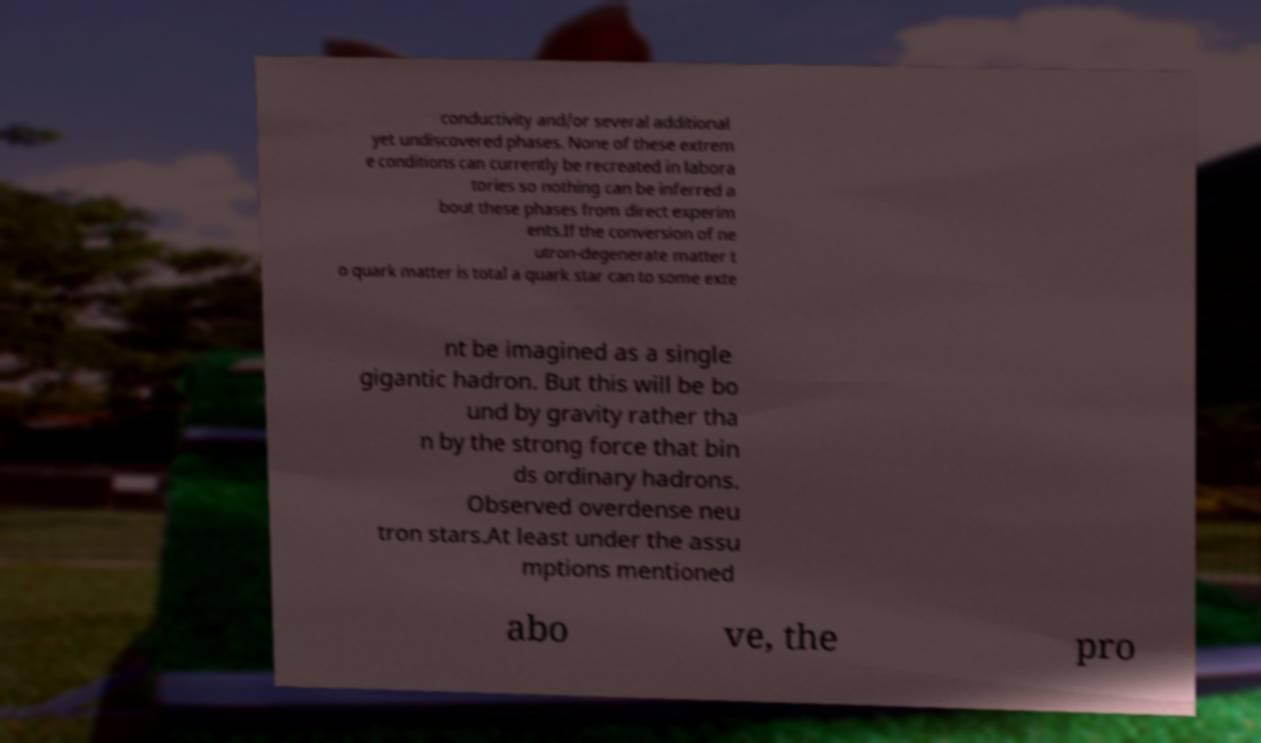Could you extract and type out the text from this image? conductivity and/or several additional yet undiscovered phases. None of these extrem e conditions can currently be recreated in labora tories so nothing can be inferred a bout these phases from direct experim ents.If the conversion of ne utron-degenerate matter t o quark matter is total a quark star can to some exte nt be imagined as a single gigantic hadron. But this will be bo und by gravity rather tha n by the strong force that bin ds ordinary hadrons. Observed overdense neu tron stars.At least under the assu mptions mentioned abo ve, the pro 